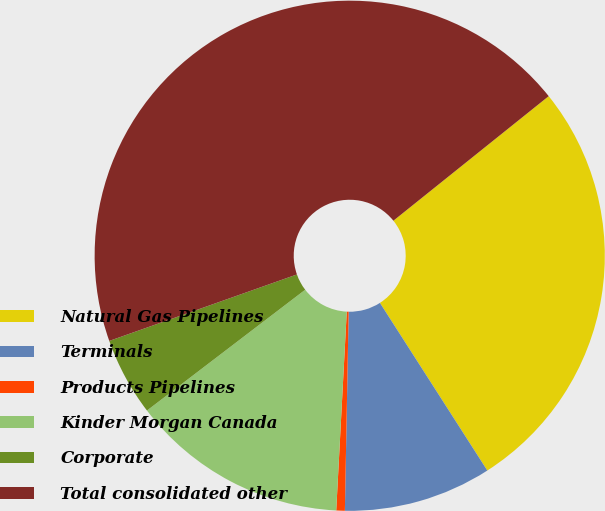Convert chart to OTSL. <chart><loc_0><loc_0><loc_500><loc_500><pie_chart><fcel>Natural Gas Pipelines<fcel>Terminals<fcel>Products Pipelines<fcel>Kinder Morgan Canada<fcel>Corporate<fcel>Total consolidated other<nl><fcel>26.69%<fcel>9.37%<fcel>0.54%<fcel>13.78%<fcel>4.96%<fcel>44.66%<nl></chart> 